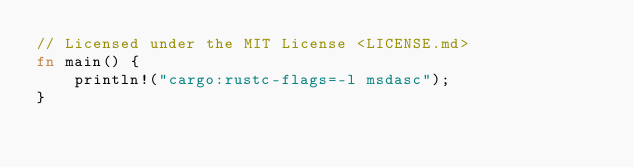Convert code to text. <code><loc_0><loc_0><loc_500><loc_500><_Rust_>// Licensed under the MIT License <LICENSE.md>
fn main() {
    println!("cargo:rustc-flags=-l msdasc");
}
</code> 